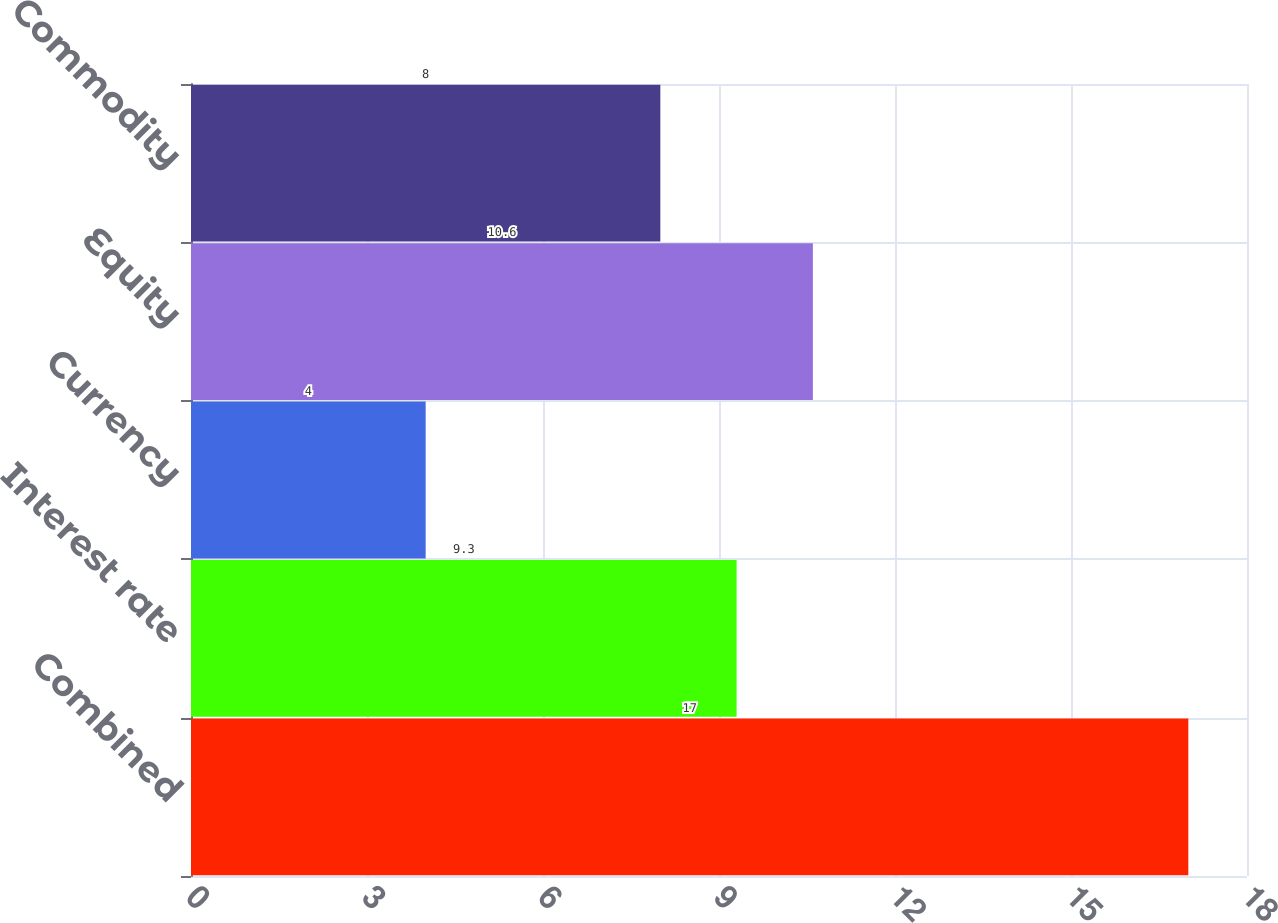<chart> <loc_0><loc_0><loc_500><loc_500><bar_chart><fcel>Combined<fcel>Interest rate<fcel>Currency<fcel>Equity<fcel>Commodity<nl><fcel>17<fcel>9.3<fcel>4<fcel>10.6<fcel>8<nl></chart> 